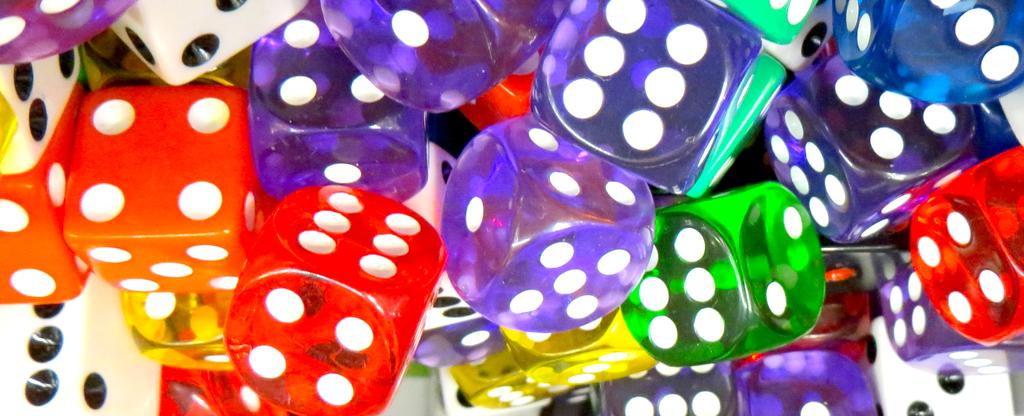What type of objects are featured in the image? There are colorful dice in the image. Can you describe the appearance of the dice? The dice are colorful, which suggests they have different colors on their sides. What might the dice be used for? The dice might be used for games or entertainment. What type of underwear can be seen on the dice in the image? There is no underwear present on the dice in the image. How many pies are visible on the dice in the image? There are no pies present on the dice in the image. 